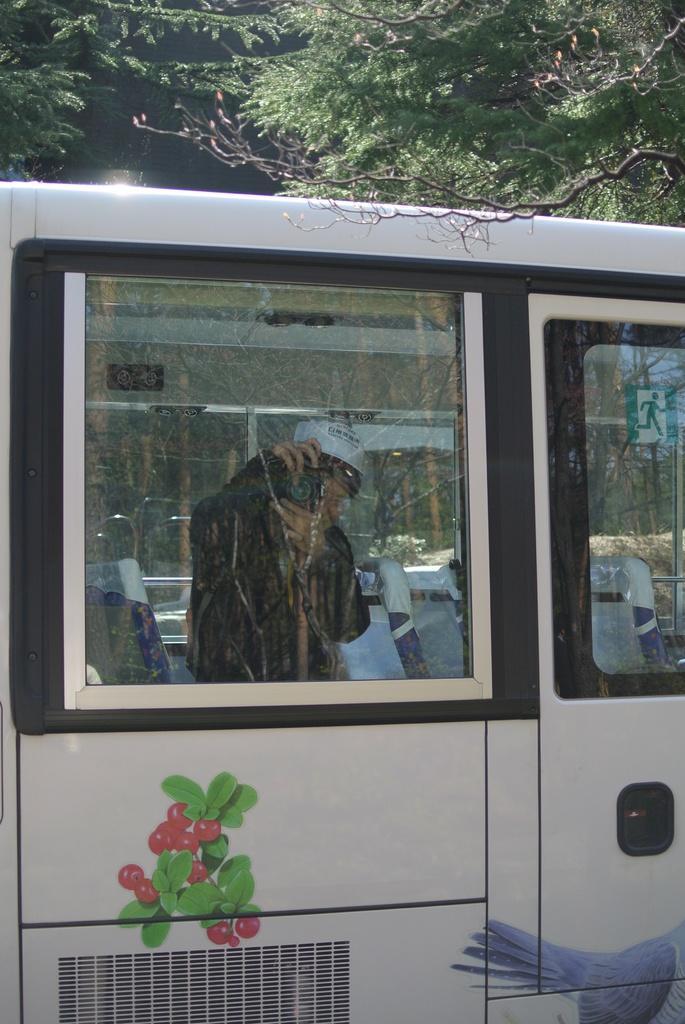Please provide a concise description of this image. In the foreground of this image, there is a vehicle and we can see through the glass window, there is a person inside it holding a camera. On the top, there are trees. 